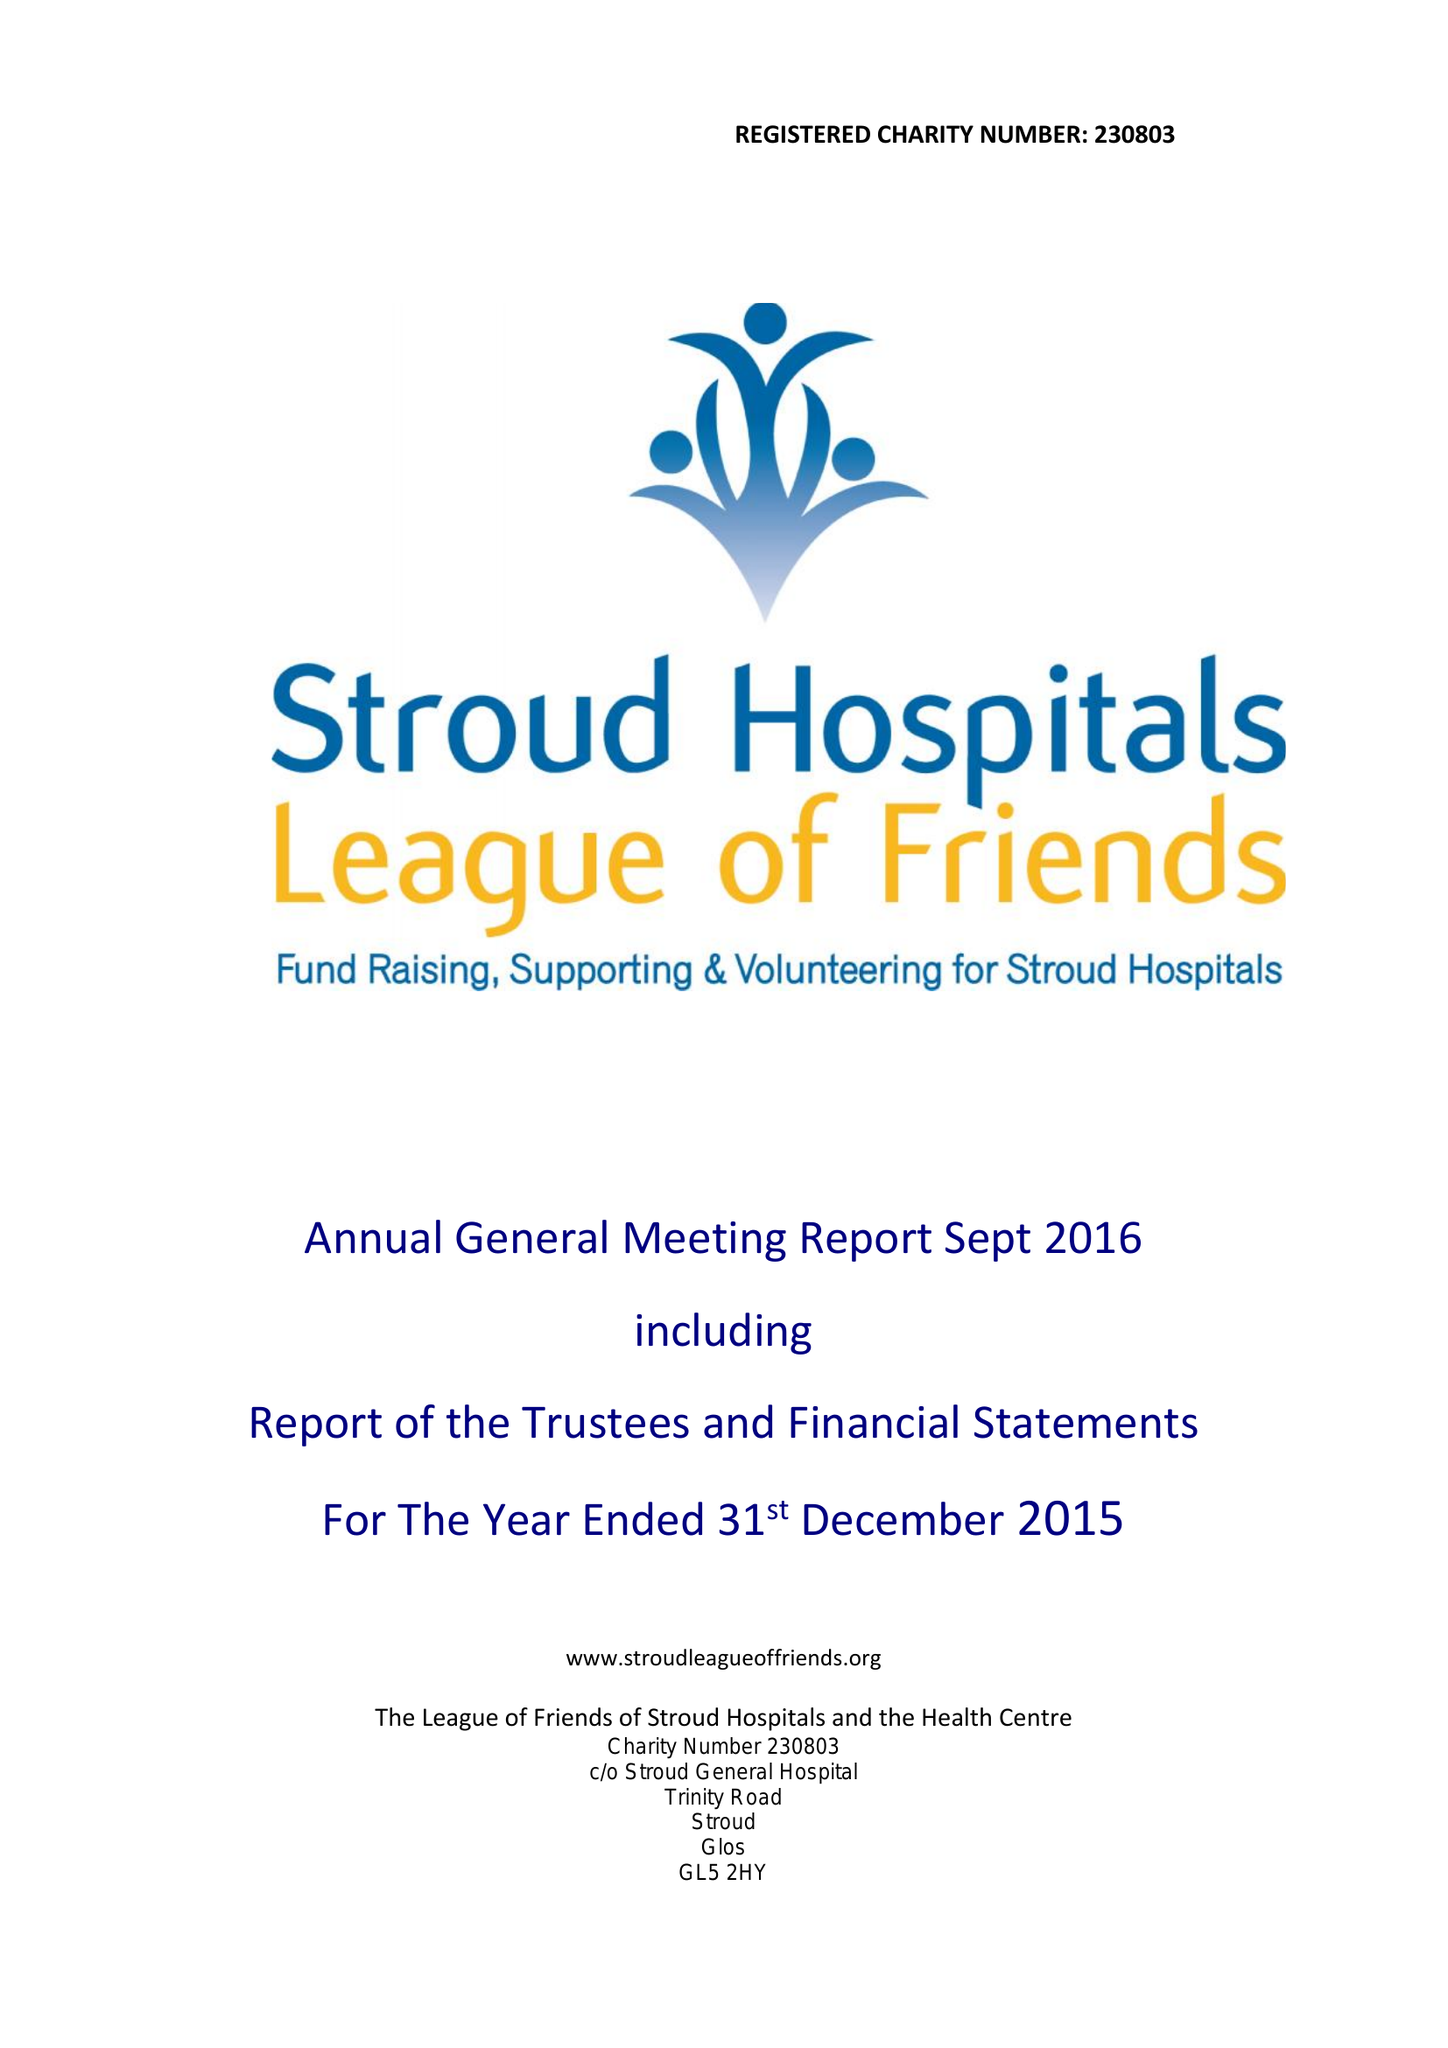What is the value for the address__street_line?
Answer the question using a single word or phrase. None 